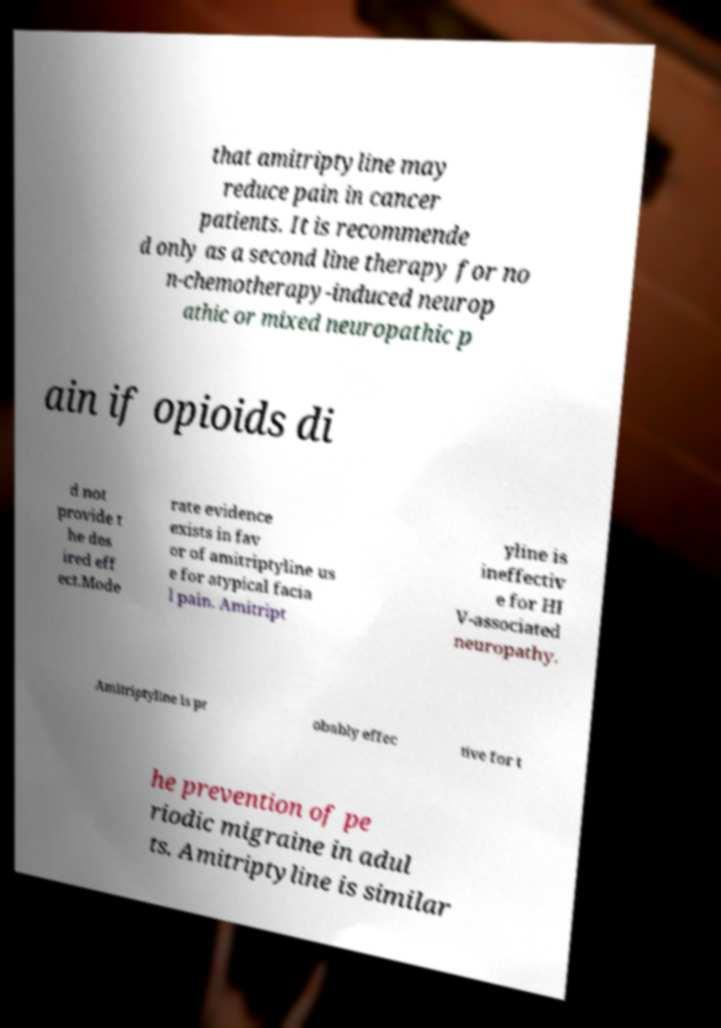I need the written content from this picture converted into text. Can you do that? that amitriptyline may reduce pain in cancer patients. It is recommende d only as a second line therapy for no n-chemotherapy-induced neurop athic or mixed neuropathic p ain if opioids di d not provide t he des ired eff ect.Mode rate evidence exists in fav or of amitriptyline us e for atypical facia l pain. Amitript yline is ineffectiv e for HI V-associated neuropathy. Amitriptyline is pr obably effec tive for t he prevention of pe riodic migraine in adul ts. Amitriptyline is similar 